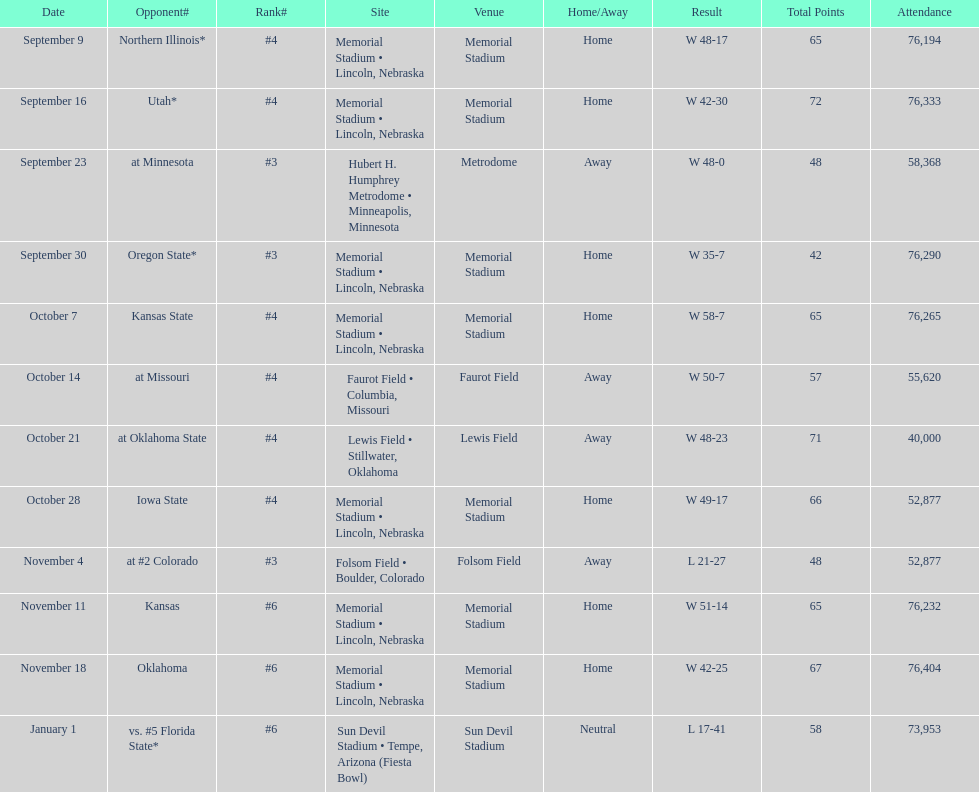When is the first game? September 9. 